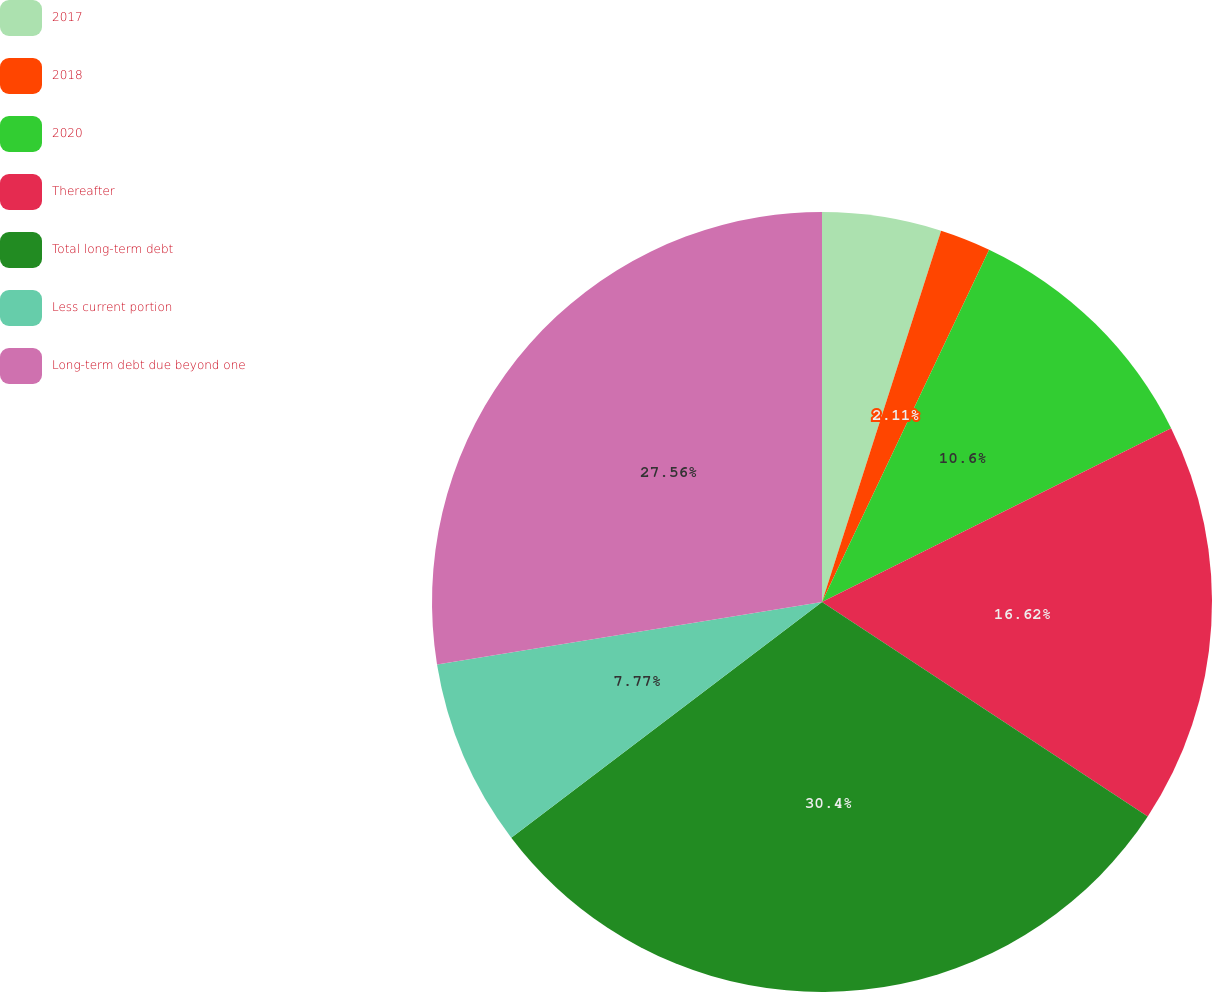Convert chart. <chart><loc_0><loc_0><loc_500><loc_500><pie_chart><fcel>2017<fcel>2018<fcel>2020<fcel>Thereafter<fcel>Total long-term debt<fcel>Less current portion<fcel>Long-term debt due beyond one<nl><fcel>4.94%<fcel>2.11%<fcel>10.6%<fcel>16.62%<fcel>30.41%<fcel>7.77%<fcel>27.56%<nl></chart> 